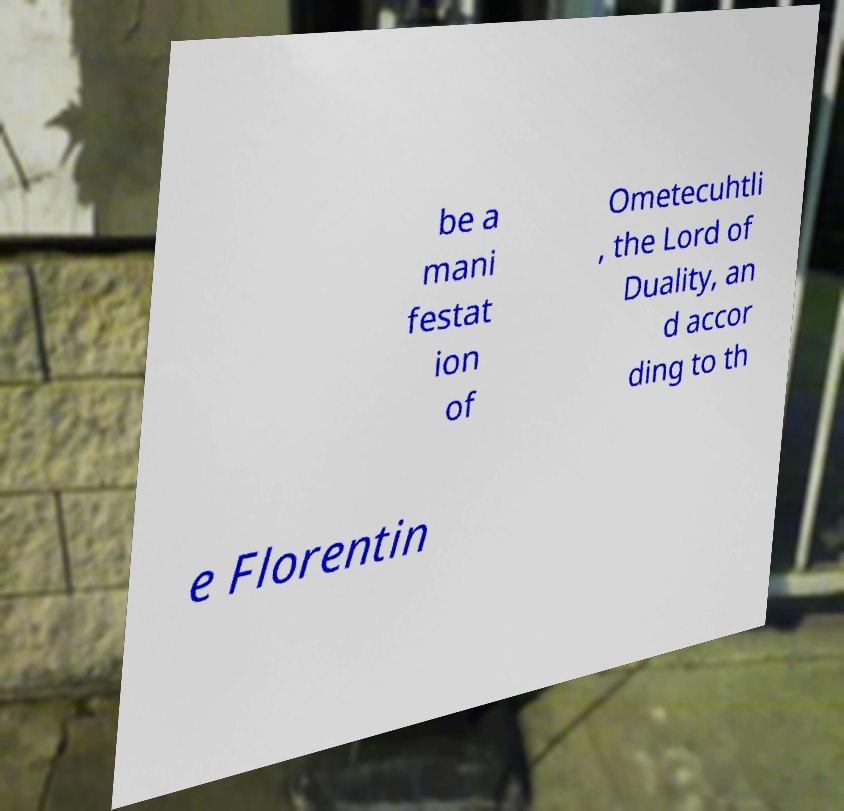Please read and relay the text visible in this image. What does it say? be a mani festat ion of Ometecuhtli , the Lord of Duality, an d accor ding to th e Florentin 